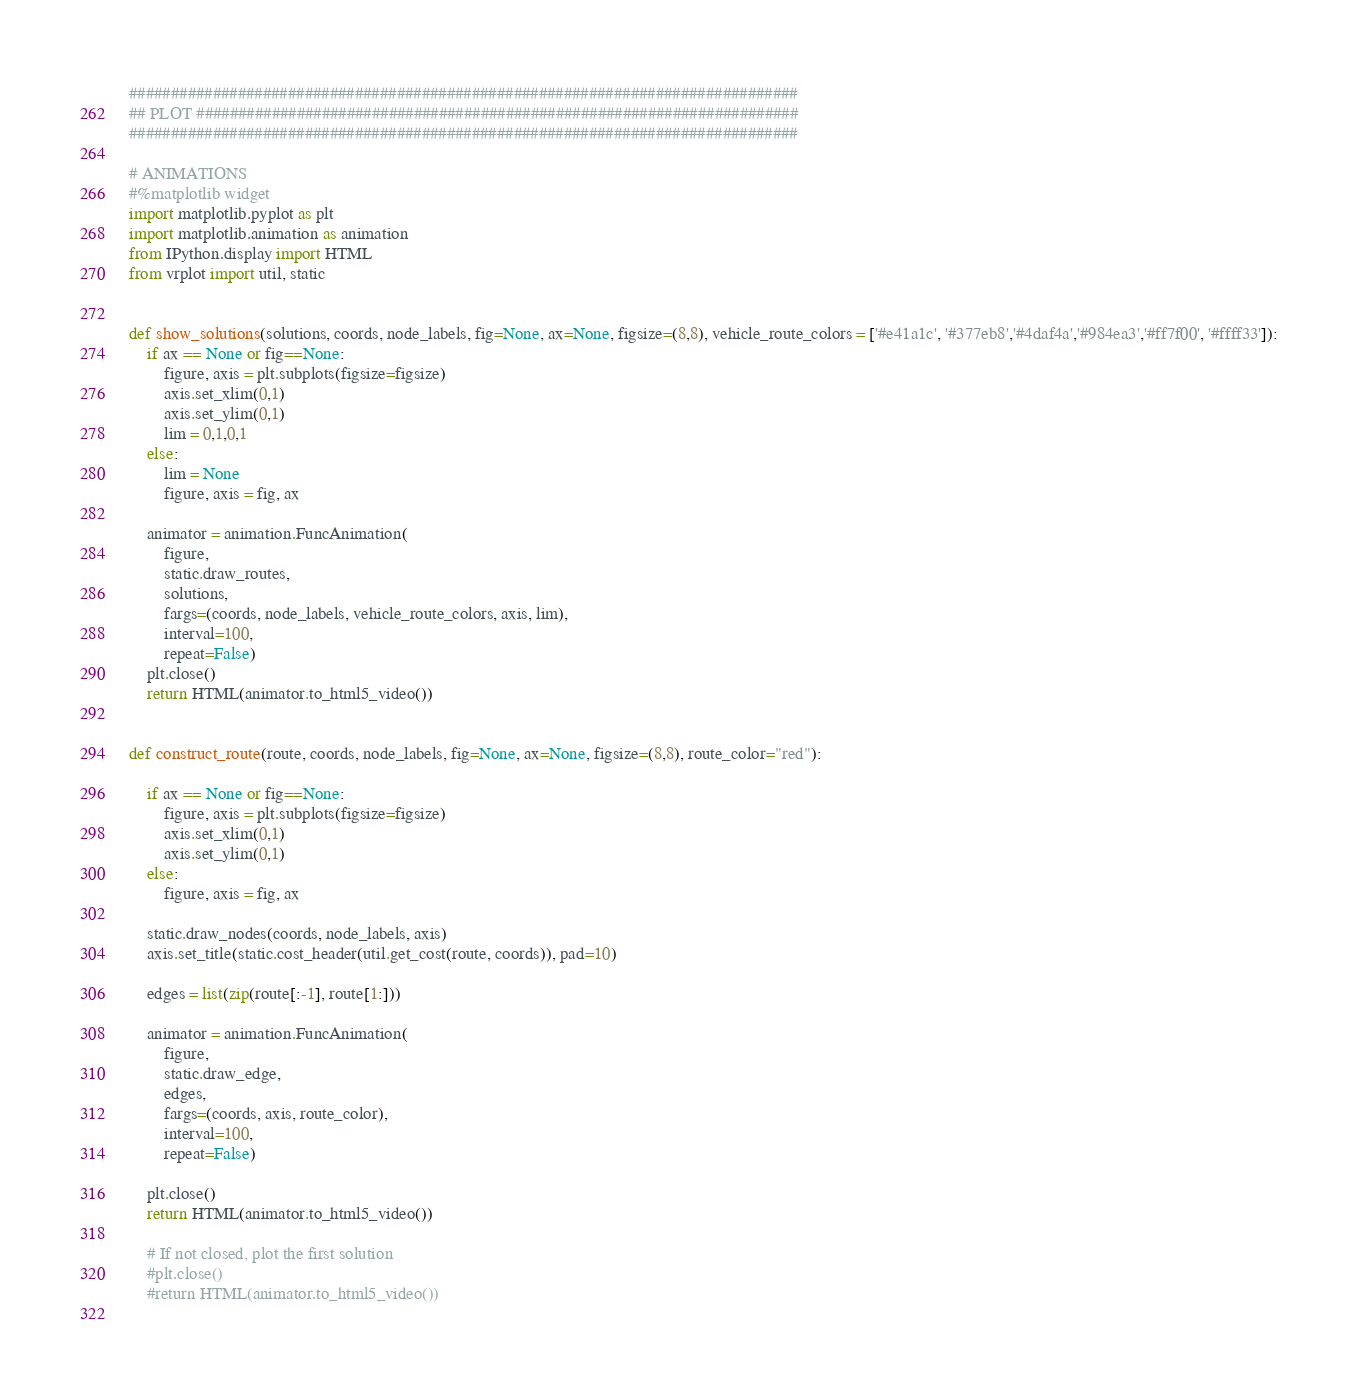Convert code to text. <code><loc_0><loc_0><loc_500><loc_500><_Python_>################################################################################
## PLOT ########################################################################
################################################################################

# ANIMATIONS
#%matplotlib widget
import matplotlib.pyplot as plt
import matplotlib.animation as animation
from IPython.display import HTML
from vrplot import util, static


def show_solutions(solutions, coords, node_labels, fig=None, ax=None, figsize=(8,8), vehicle_route_colors = ['#e41a1c', '#377eb8','#4daf4a','#984ea3','#ff7f00', '#ffff33']):
    if ax == None or fig==None:
        figure, axis = plt.subplots(figsize=figsize)
        axis.set_xlim(0,1)
        axis.set_ylim(0,1)
        lim = 0,1,0,1
    else:
        lim = None
        figure, axis = fig, ax

    animator = animation.FuncAnimation(
        figure,
        static.draw_routes,
        solutions,
        fargs=(coords, node_labels, vehicle_route_colors, axis, lim),
        interval=100,
        repeat=False)
    plt.close()
    return HTML(animator.to_html5_video())


def construct_route(route, coords, node_labels, fig=None, ax=None, figsize=(8,8), route_color="red"):
    
    if ax == None or fig==None:
        figure, axis = plt.subplots(figsize=figsize)
        axis.set_xlim(0,1)
        axis.set_ylim(0,1)
    else:
        figure, axis = fig, ax
        
    static.draw_nodes(coords, node_labels, axis)        
    axis.set_title(static.cost_header(util.get_cost(route, coords)), pad=10)

    edges = list(zip(route[:-1], route[1:]))

    animator = animation.FuncAnimation(
        figure,
        static.draw_edge,
        edges,
        fargs=(coords, axis, route_color),
        interval=100,
        repeat=False)
    
    plt.close()
    return HTML(animator.to_html5_video())

    # If not closed, plot the first solution
    #plt.close()
    #return HTML(animator.to_html5_video())
  
</code> 